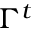<formula> <loc_0><loc_0><loc_500><loc_500>\Gamma ^ { t }</formula> 